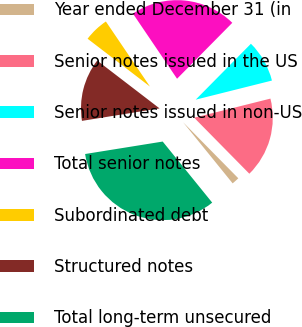Convert chart to OTSL. <chart><loc_0><loc_0><loc_500><loc_500><pie_chart><fcel>Year ended December 31 (in<fcel>Senior notes issued in the US<fcel>Senior notes issued in non-US<fcel>Total senior notes<fcel>Subordinated debt<fcel>Structured notes<fcel>Total long-term unsecured<nl><fcel>1.54%<fcel>16.53%<fcel>8.69%<fcel>21.88%<fcel>5.11%<fcel>12.95%<fcel>33.31%<nl></chart> 